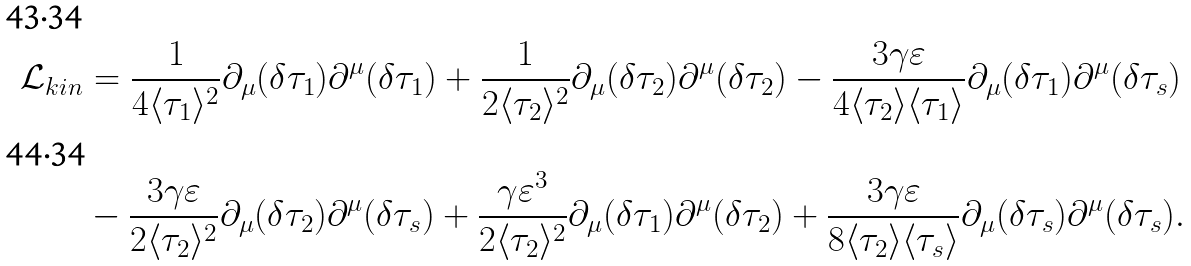Convert formula to latex. <formula><loc_0><loc_0><loc_500><loc_500>\mathcal { L } _ { k i n } & = \frac { 1 } { 4 \langle \tau _ { 1 } \rangle ^ { 2 } } \partial _ { \mu } ( \delta \tau _ { 1 } ) \partial ^ { \mu } ( \delta \tau _ { 1 } ) + \frac { 1 } { 2 \langle \tau _ { 2 } \rangle ^ { 2 } } \partial _ { \mu } ( \delta \tau _ { 2 } ) \partial ^ { \mu } ( \delta \tau _ { 2 } ) - \frac { 3 \gamma \varepsilon } { 4 \langle \tau _ { 2 } \rangle \langle \tau _ { 1 } \rangle } \partial _ { \mu } ( \delta \tau _ { 1 } ) \partial ^ { \mu } ( \delta \tau _ { s } ) \\ & - \frac { 3 \gamma \varepsilon } { 2 \langle \tau _ { 2 } \rangle ^ { 2 } } \partial _ { \mu } ( \delta \tau _ { 2 } ) \partial ^ { \mu } ( \delta \tau _ { s } ) + \frac { \gamma \varepsilon ^ { 3 } } { 2 \langle \tau _ { 2 } \rangle ^ { 2 } } \partial _ { \mu } ( \delta \tau _ { 1 } ) \partial ^ { \mu } ( \delta \tau _ { 2 } ) + \frac { 3 \gamma \varepsilon } { 8 \langle \tau _ { 2 } \rangle \langle \tau _ { s } \rangle } \partial _ { \mu } ( \delta \tau _ { s } ) \partial ^ { \mu } ( \delta \tau _ { s } ) .</formula> 